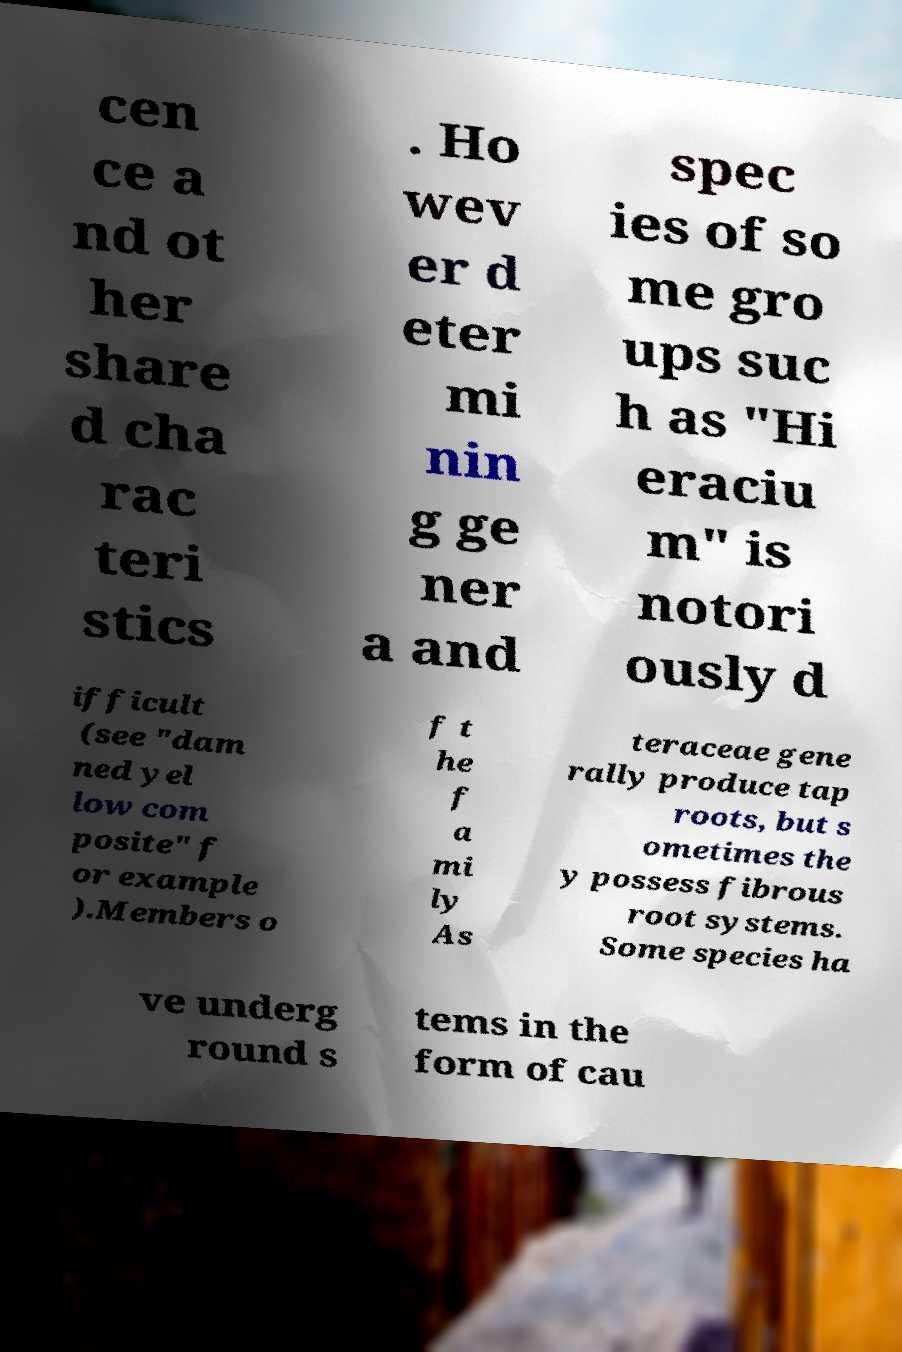Can you read and provide the text displayed in the image?This photo seems to have some interesting text. Can you extract and type it out for me? cen ce a nd ot her share d cha rac teri stics . Ho wev er d eter mi nin g ge ner a and spec ies of so me gro ups suc h as "Hi eraciu m" is notori ously d ifficult (see "dam ned yel low com posite" f or example ).Members o f t he f a mi ly As teraceae gene rally produce tap roots, but s ometimes the y possess fibrous root systems. Some species ha ve underg round s tems in the form of cau 